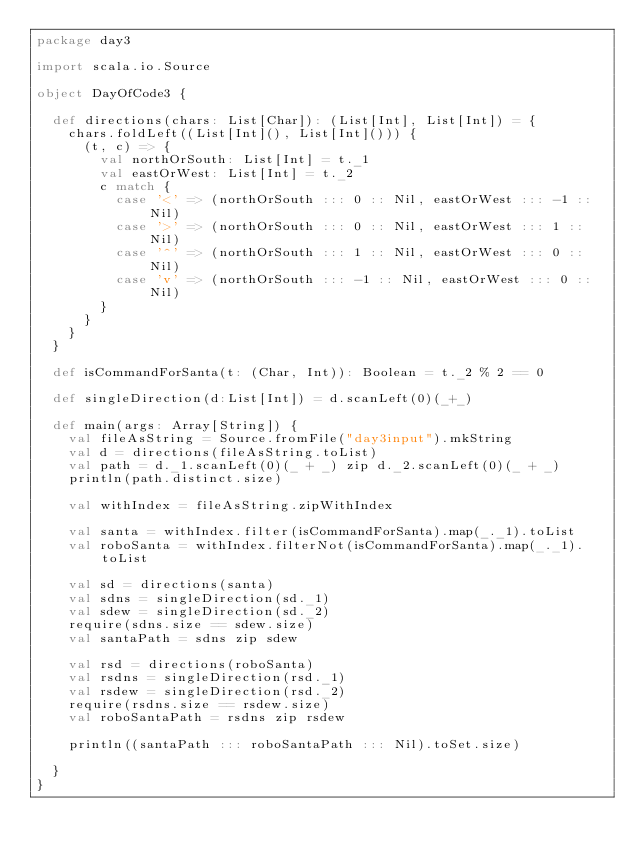<code> <loc_0><loc_0><loc_500><loc_500><_Scala_>package day3

import scala.io.Source

object DayOfCode3 {

  def directions(chars: List[Char]): (List[Int], List[Int]) = {
    chars.foldLeft((List[Int](), List[Int]())) {
      (t, c) => {
        val northOrSouth: List[Int] = t._1
        val eastOrWest: List[Int] = t._2
        c match {
          case '<' => (northOrSouth ::: 0 :: Nil, eastOrWest ::: -1 :: Nil)
          case '>' => (northOrSouth ::: 0 :: Nil, eastOrWest ::: 1 :: Nil)
          case '^' => (northOrSouth ::: 1 :: Nil, eastOrWest ::: 0 :: Nil)
          case 'v' => (northOrSouth ::: -1 :: Nil, eastOrWest ::: 0 :: Nil)
        }
      }
    }
  }

  def isCommandForSanta(t: (Char, Int)): Boolean = t._2 % 2 == 0

  def singleDirection(d:List[Int]) = d.scanLeft(0)(_+_)

  def main(args: Array[String]) {
    val fileAsString = Source.fromFile("day3input").mkString
    val d = directions(fileAsString.toList)
    val path = d._1.scanLeft(0)(_ + _) zip d._2.scanLeft(0)(_ + _)
    println(path.distinct.size)

    val withIndex = fileAsString.zipWithIndex

    val santa = withIndex.filter(isCommandForSanta).map(_._1).toList
    val roboSanta = withIndex.filterNot(isCommandForSanta).map(_._1).toList

    val sd = directions(santa)
    val sdns = singleDirection(sd._1)
    val sdew = singleDirection(sd._2)
    require(sdns.size == sdew.size)
    val santaPath = sdns zip sdew

    val rsd = directions(roboSanta)
    val rsdns = singleDirection(rsd._1)
    val rsdew = singleDirection(rsd._2)
    require(rsdns.size == rsdew.size)
    val roboSantaPath = rsdns zip rsdew

    println((santaPath ::: roboSantaPath ::: Nil).toSet.size)

  }
}
</code> 